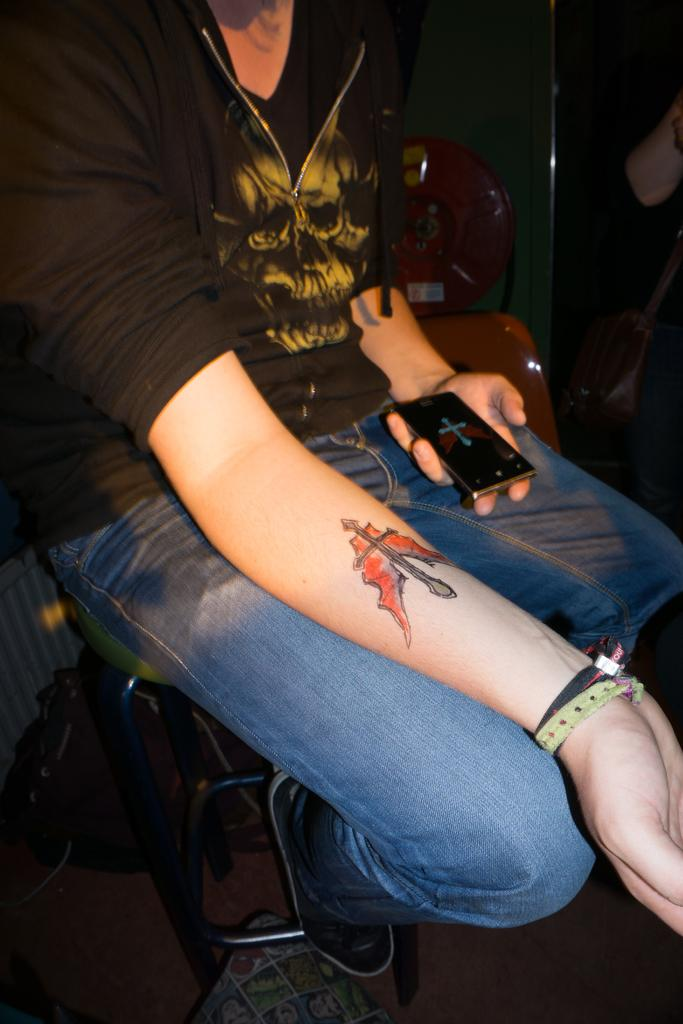Who is the main subject in the image? There is a woman in the image. What is the woman doing in the image? The woman is sitting on a chair. Can you describe any distinguishing features of the woman? The woman has a tattoo on her arm. What object is the woman holding in her hand? The woman is holding a mobile phone in her hand. What industry is the woman working in, as depicted in the image? The image does not provide any information about the woman's industry. 